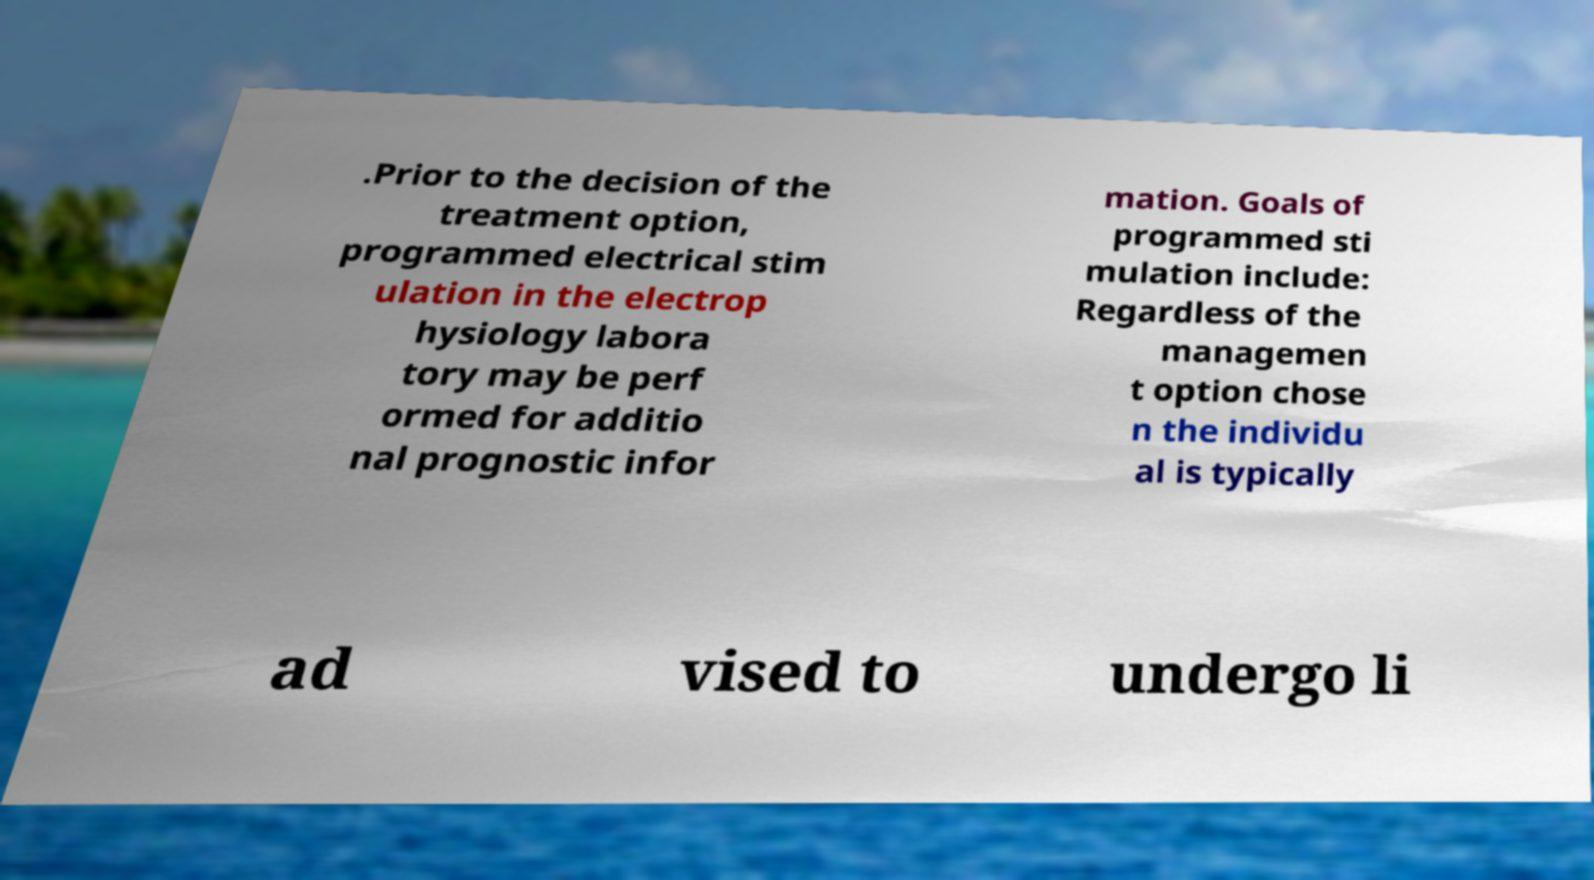Please identify and transcribe the text found in this image. .Prior to the decision of the treatment option, programmed electrical stim ulation in the electrop hysiology labora tory may be perf ormed for additio nal prognostic infor mation. Goals of programmed sti mulation include: Regardless of the managemen t option chose n the individu al is typically ad vised to undergo li 